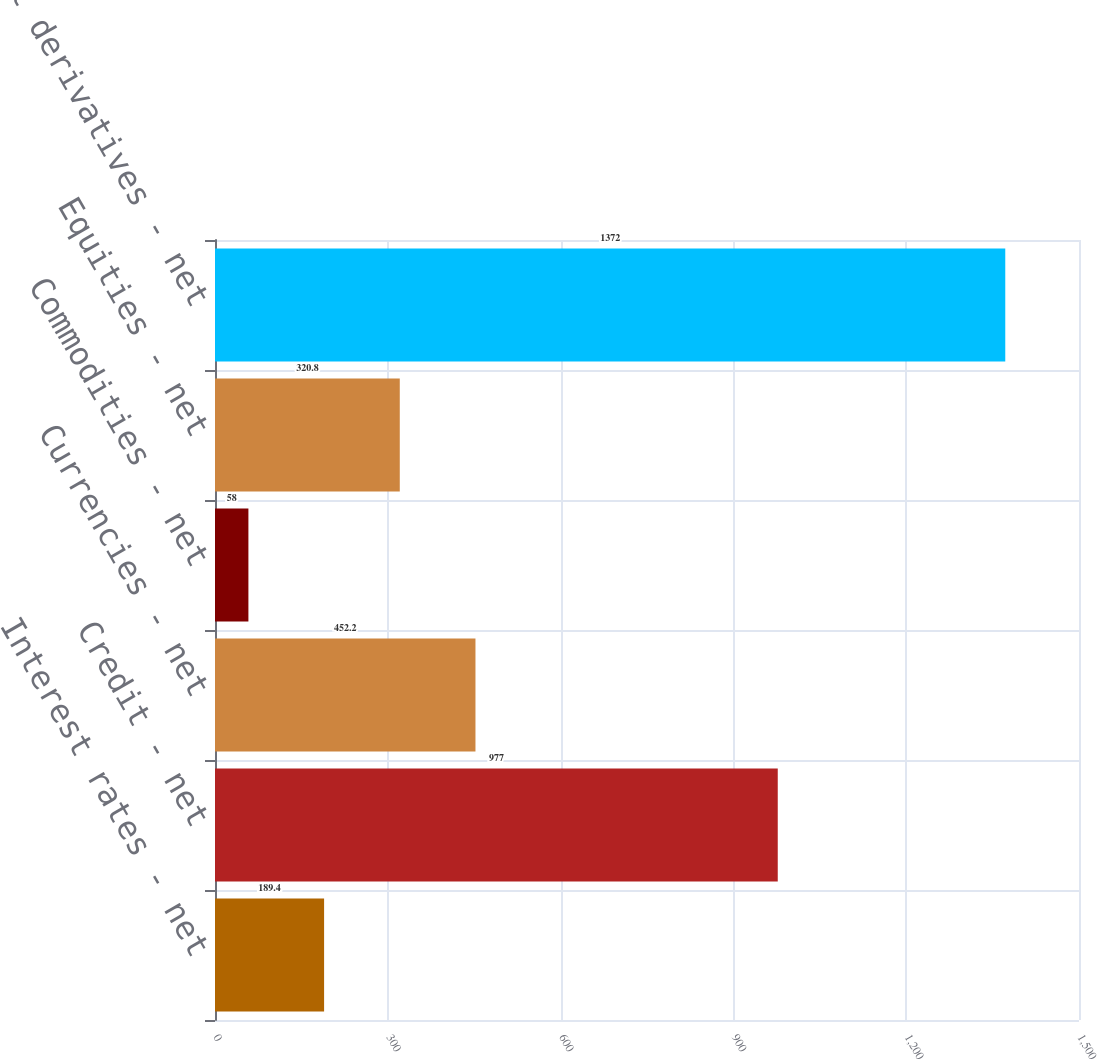<chart> <loc_0><loc_0><loc_500><loc_500><bar_chart><fcel>Interest rates - net<fcel>Credit - net<fcel>Currencies - net<fcel>Commodities - net<fcel>Equities - net<fcel>Total derivatives - net<nl><fcel>189.4<fcel>977<fcel>452.2<fcel>58<fcel>320.8<fcel>1372<nl></chart> 